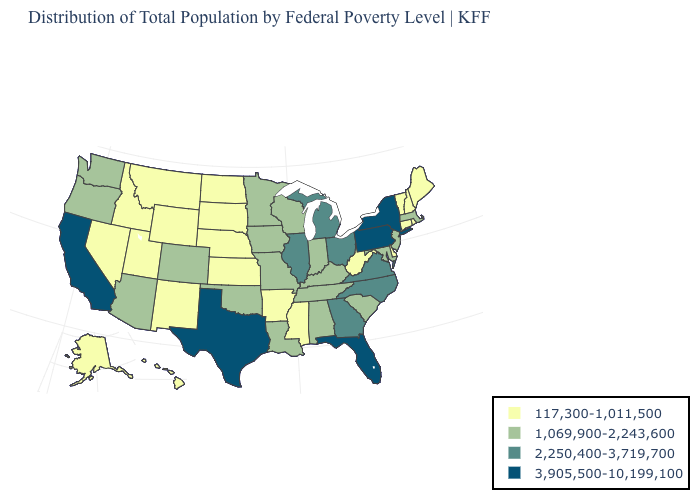What is the value of Maryland?
Concise answer only. 1,069,900-2,243,600. Does the map have missing data?
Give a very brief answer. No. What is the value of New Hampshire?
Write a very short answer. 117,300-1,011,500. Name the states that have a value in the range 2,250,400-3,719,700?
Be succinct. Georgia, Illinois, Michigan, North Carolina, Ohio, Virginia. Among the states that border Mississippi , which have the lowest value?
Be succinct. Arkansas. Among the states that border Wyoming , which have the highest value?
Keep it brief. Colorado. What is the value of Hawaii?
Short answer required. 117,300-1,011,500. What is the highest value in the Northeast ?
Answer briefly. 3,905,500-10,199,100. Does Pennsylvania have the highest value in the USA?
Answer briefly. Yes. Among the states that border Washington , which have the highest value?
Give a very brief answer. Oregon. What is the value of Illinois?
Keep it brief. 2,250,400-3,719,700. What is the value of Illinois?
Write a very short answer. 2,250,400-3,719,700. What is the highest value in the USA?
Quick response, please. 3,905,500-10,199,100. What is the value of New York?
Keep it brief. 3,905,500-10,199,100. Does the first symbol in the legend represent the smallest category?
Be succinct. Yes. 